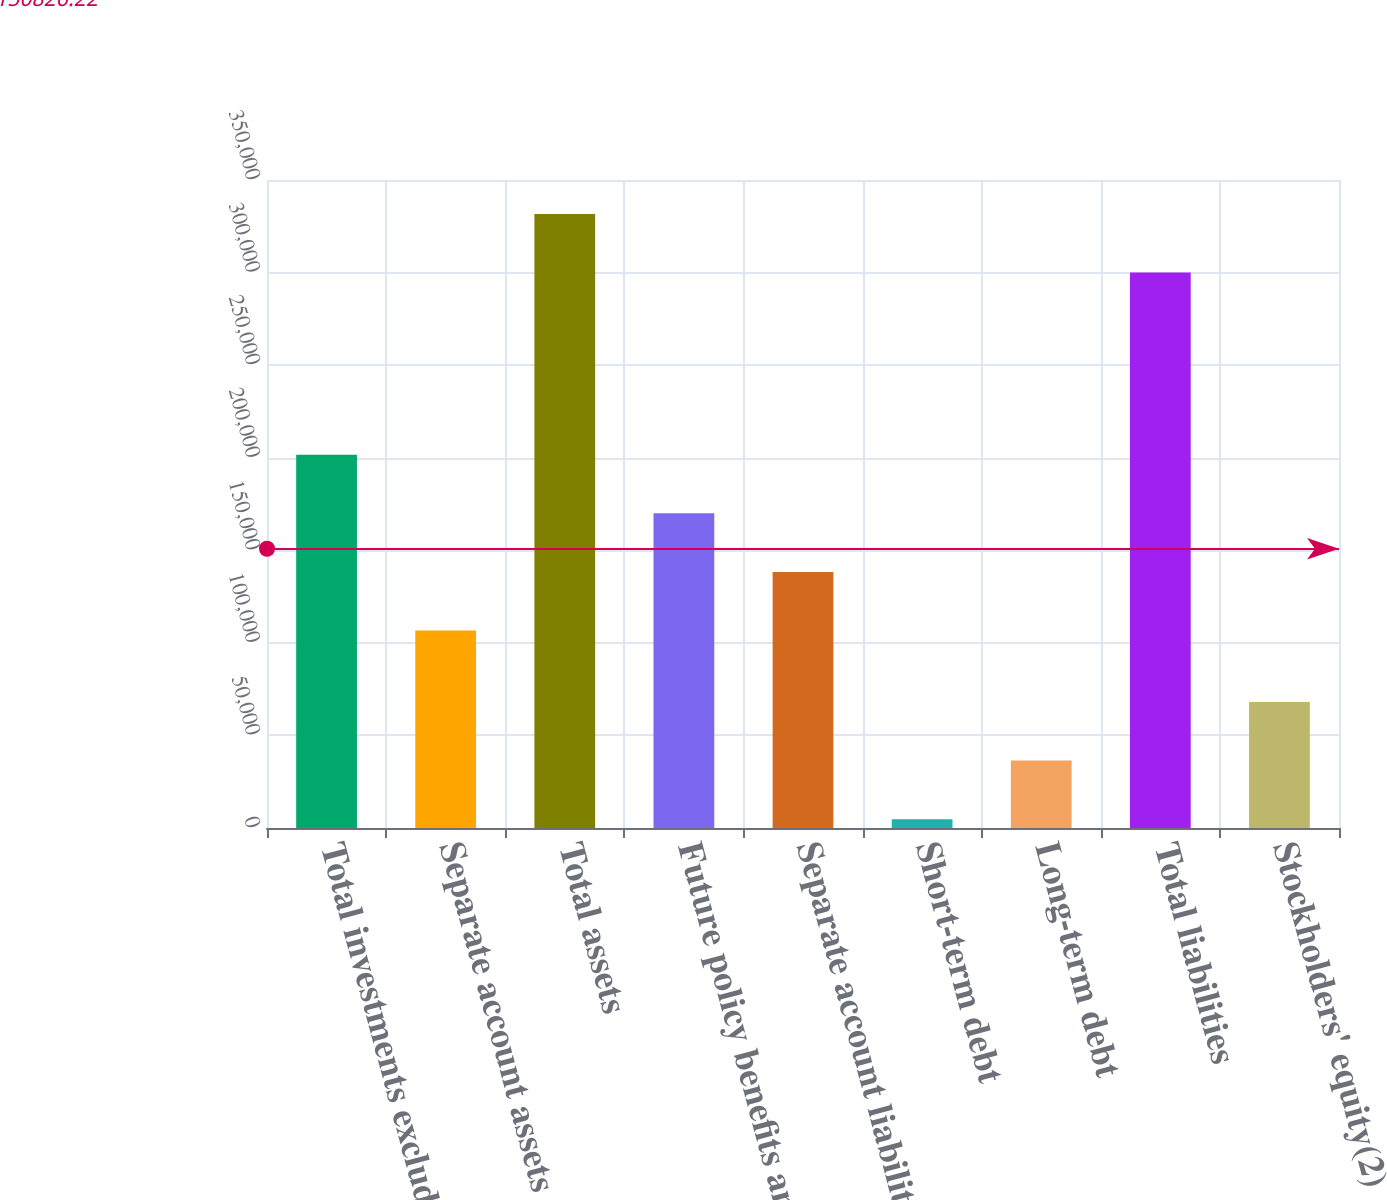<chart> <loc_0><loc_0><loc_500><loc_500><bar_chart><fcel>Total investments excluding<fcel>Separate account assets<fcel>Total assets<fcel>Future policy benefits and<fcel>Separate account liabilities<fcel>Short-term debt<fcel>Long-term debt<fcel>Total liabilities<fcel>Stockholders' equity(2)<nl><fcel>201640<fcel>106680<fcel>331636<fcel>169987<fcel>138334<fcel>4739<fcel>36392.5<fcel>299982<fcel>68046<nl></chart> 